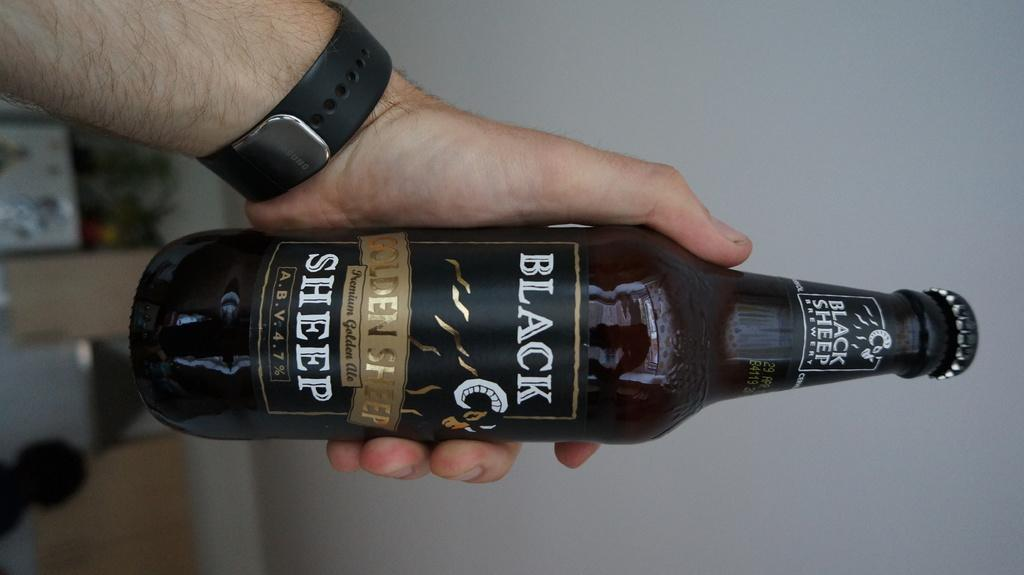<image>
Relay a brief, clear account of the picture shown. A man holds a bottle of beer titled BLACK SHEEP. 